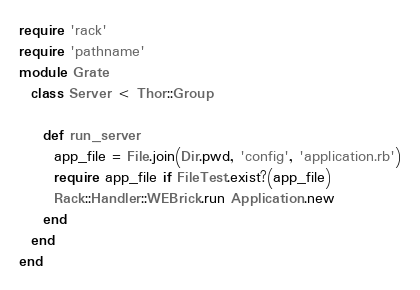<code> <loc_0><loc_0><loc_500><loc_500><_Ruby_>require 'rack'
require 'pathname'
module Grate
  class Server < Thor::Group

    def run_server
      app_file = File.join(Dir.pwd, 'config', 'application.rb')
      require app_file if FileTest.exist?(app_file)
      Rack::Handler::WEBrick.run Application.new
    end
  end
end
</code> 